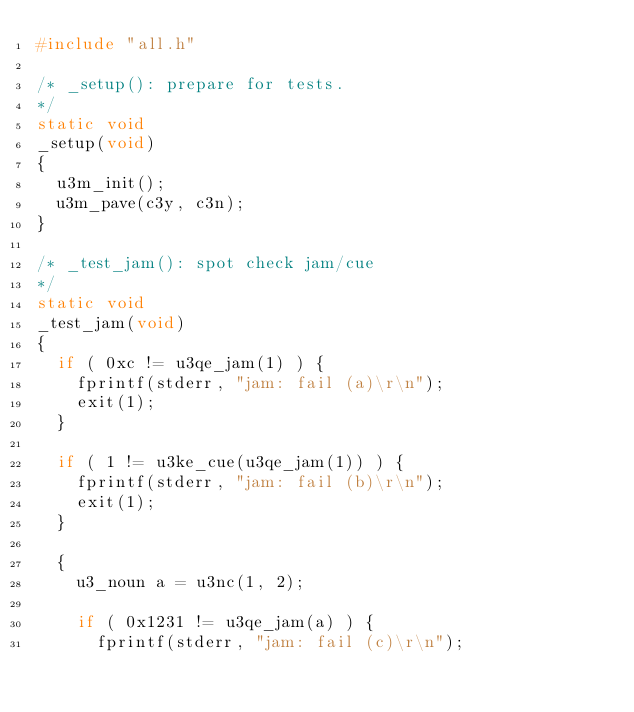Convert code to text. <code><loc_0><loc_0><loc_500><loc_500><_C_>#include "all.h"

/* _setup(): prepare for tests.
*/
static void
_setup(void)
{
  u3m_init();
  u3m_pave(c3y, c3n);
}

/* _test_jam(): spot check jam/cue
*/
static void
_test_jam(void)
{
  if ( 0xc != u3qe_jam(1) ) {
    fprintf(stderr, "jam: fail (a)\r\n");
    exit(1);
  }

  if ( 1 != u3ke_cue(u3qe_jam(1)) ) {
    fprintf(stderr, "jam: fail (b)\r\n");
    exit(1);
  }

  {
    u3_noun a = u3nc(1, 2);

    if ( 0x1231 != u3qe_jam(a) ) {
      fprintf(stderr, "jam: fail (c)\r\n");</code> 